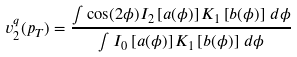Convert formula to latex. <formula><loc_0><loc_0><loc_500><loc_500>v _ { 2 } ^ { q } ( p _ { T } ) = \frac { \int \cos ( 2 \phi ) I _ { 2 } \left [ a ( \phi ) \right ] K _ { 1 } \left [ b ( \phi ) \right ] \, d \phi } { \int I _ { 0 } \left [ a ( \phi ) \right ] K _ { 1 } \left [ b ( \phi ) \right ] \, d \phi }</formula> 